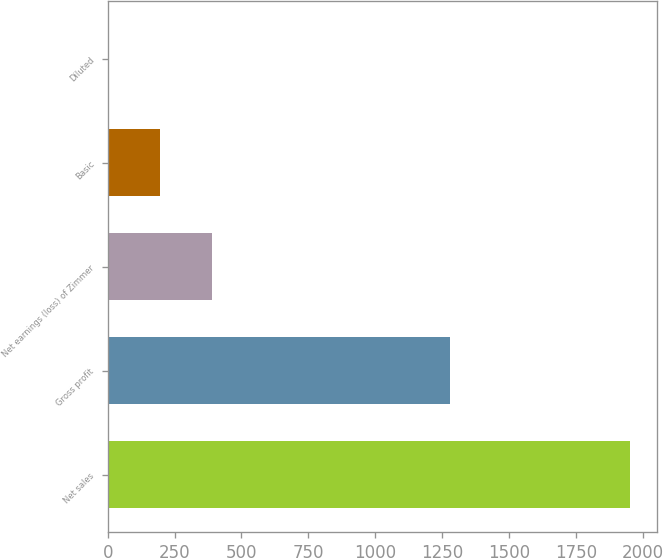Convert chart. <chart><loc_0><loc_0><loc_500><loc_500><bar_chart><fcel>Net sales<fcel>Gross profit<fcel>Net earnings (loss) of Zimmer<fcel>Basic<fcel>Diluted<nl><fcel>1954.4<fcel>1279<fcel>391.6<fcel>196.25<fcel>0.9<nl></chart> 